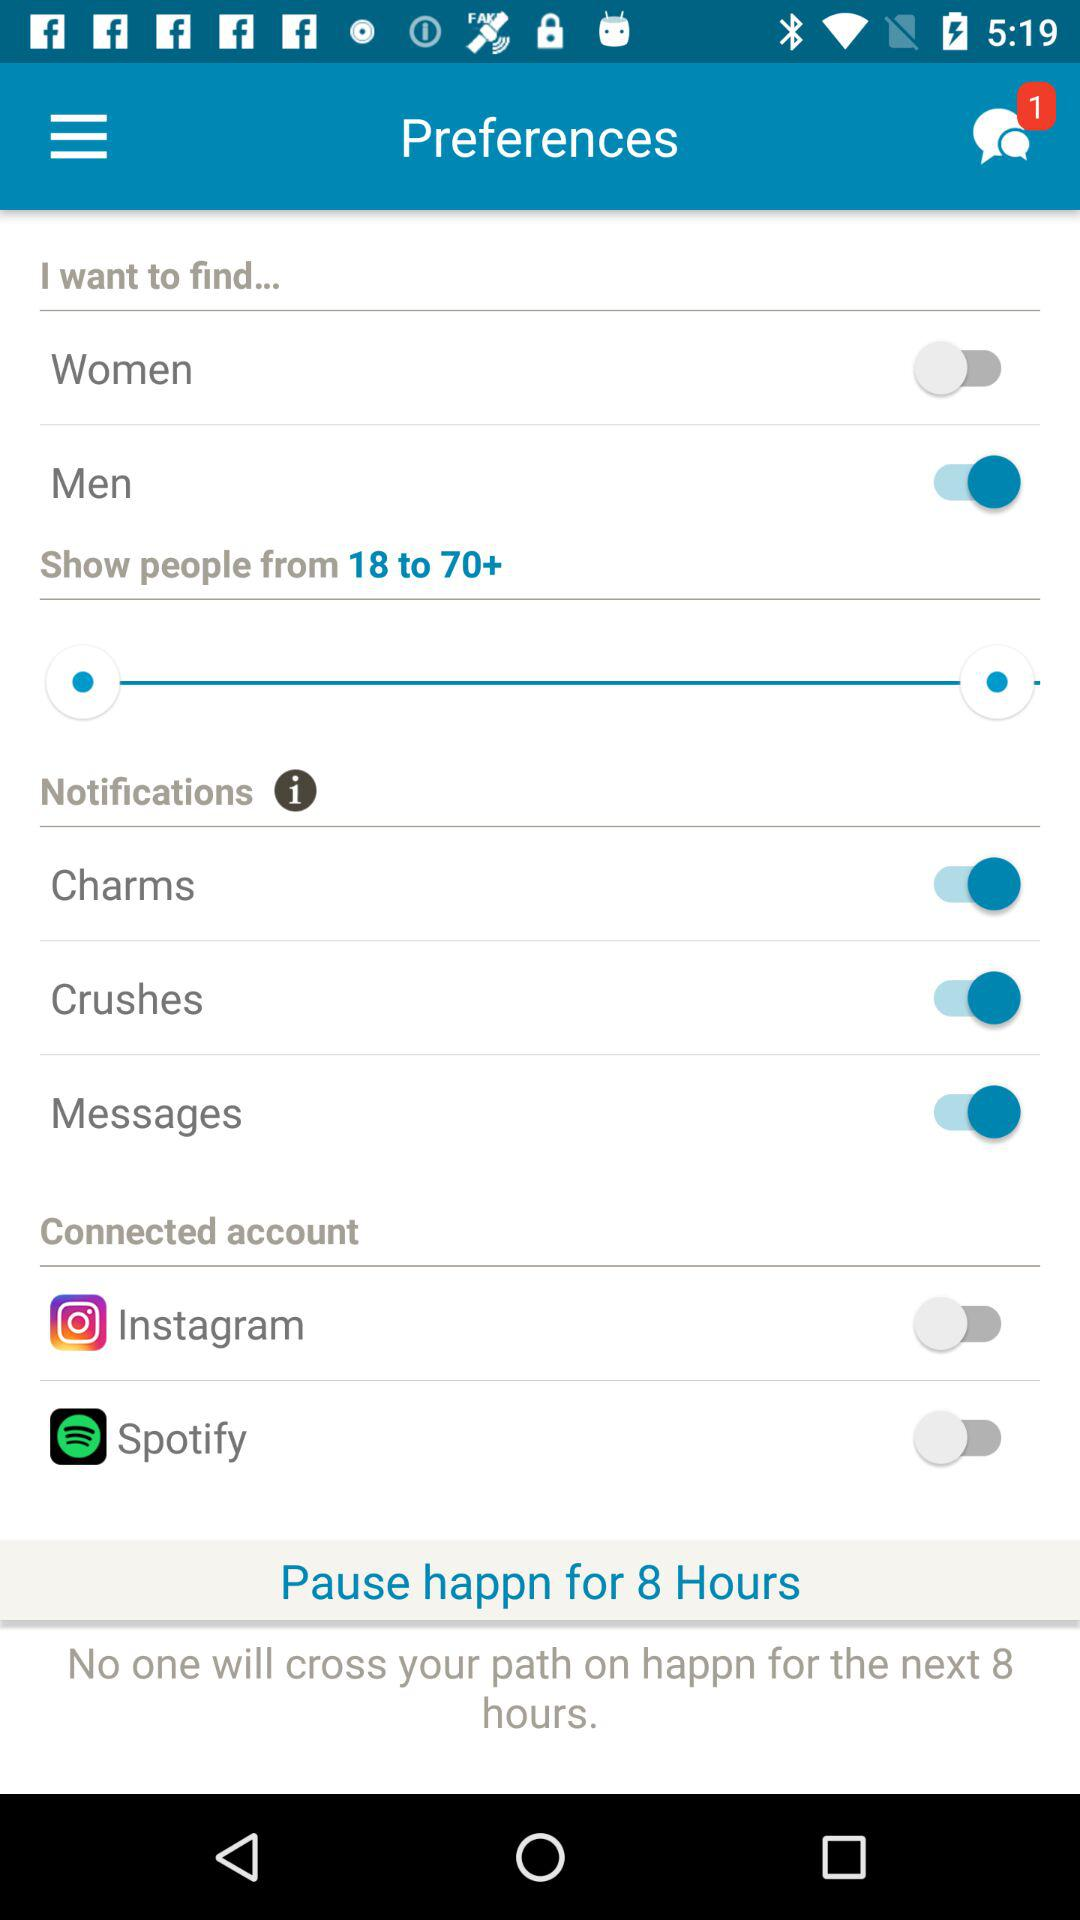What is the selected age range? The selected age range is 18 to 70+. 